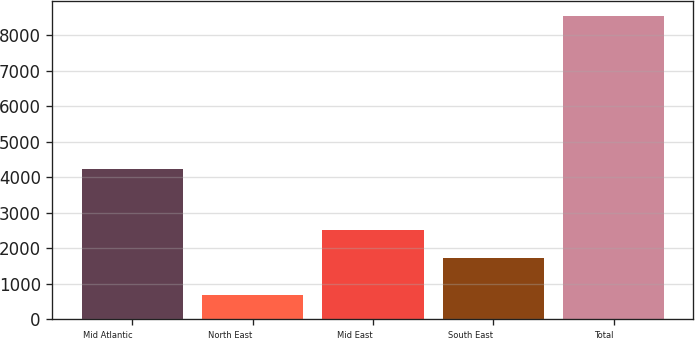Convert chart. <chart><loc_0><loc_0><loc_500><loc_500><bar_chart><fcel>Mid Atlantic<fcel>North East<fcel>Mid East<fcel>South East<fcel>Total<nl><fcel>4224<fcel>682<fcel>2511.9<fcel>1727<fcel>8531<nl></chart> 